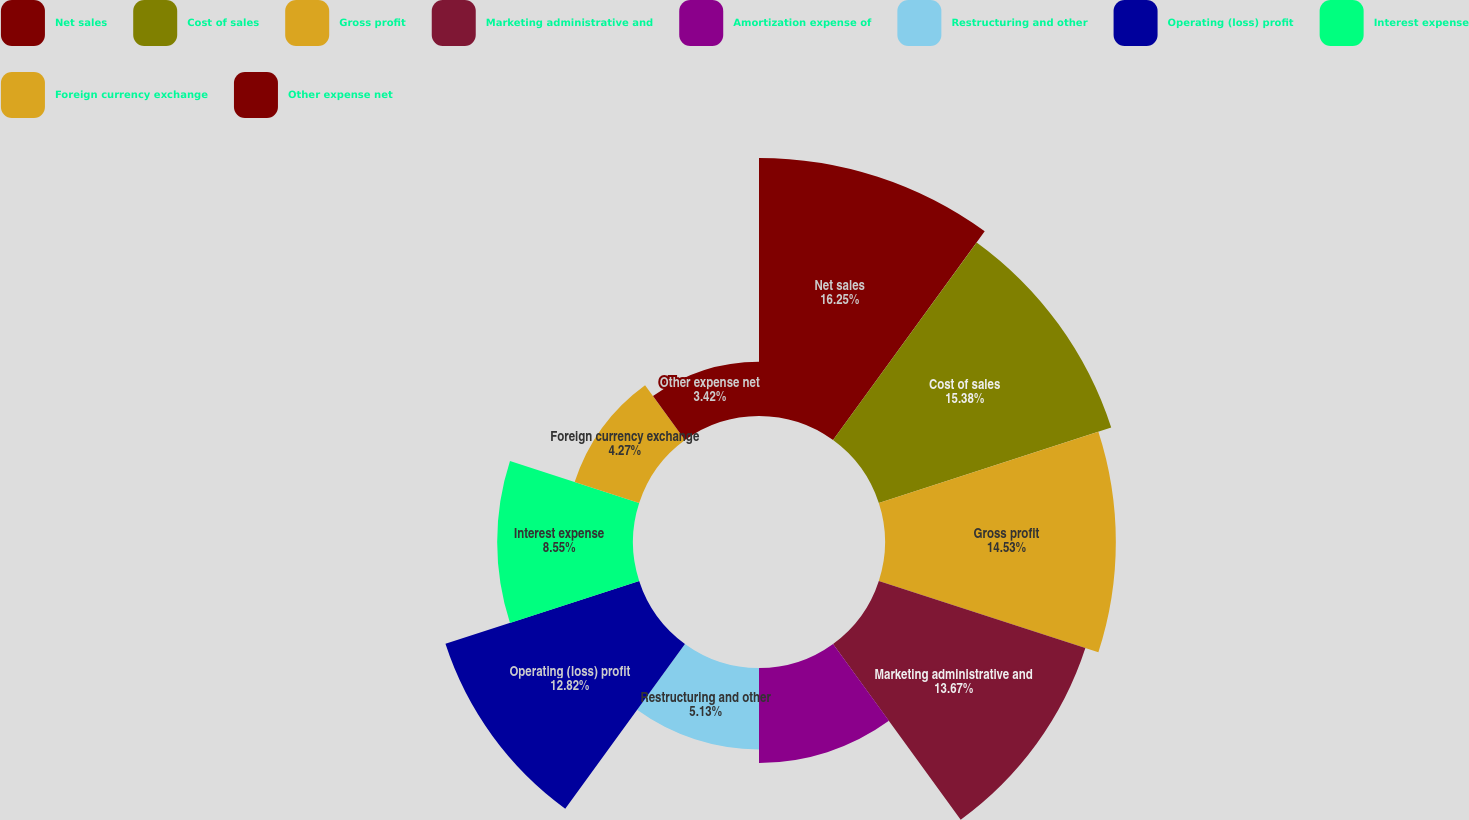Convert chart to OTSL. <chart><loc_0><loc_0><loc_500><loc_500><pie_chart><fcel>Net sales<fcel>Cost of sales<fcel>Gross profit<fcel>Marketing administrative and<fcel>Amortization expense of<fcel>Restructuring and other<fcel>Operating (loss) profit<fcel>Interest expense<fcel>Foreign currency exchange<fcel>Other expense net<nl><fcel>16.24%<fcel>15.38%<fcel>14.53%<fcel>13.67%<fcel>5.98%<fcel>5.13%<fcel>12.82%<fcel>8.55%<fcel>4.27%<fcel>3.42%<nl></chart> 